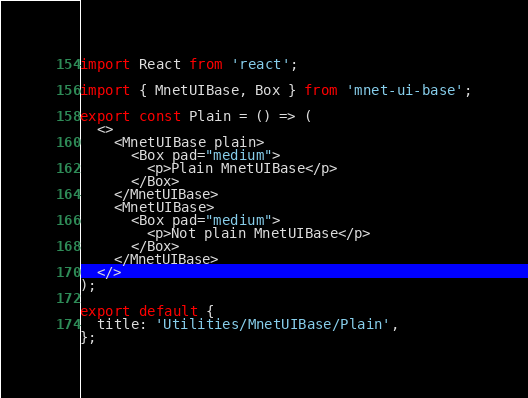Convert code to text. <code><loc_0><loc_0><loc_500><loc_500><_JavaScript_>import React from 'react';

import { MnetUIBase, Box } from 'mnet-ui-base';

export const Plain = () => (
  <>
    <MnetUIBase plain>
      <Box pad="medium">
        <p>Plain MnetUIBase</p>
      </Box>
    </MnetUIBase>
    <MnetUIBase>
      <Box pad="medium">
        <p>Not plain MnetUIBase</p>
      </Box>
    </MnetUIBase>
  </>
);

export default {
  title: 'Utilities/MnetUIBase/Plain',
};
</code> 